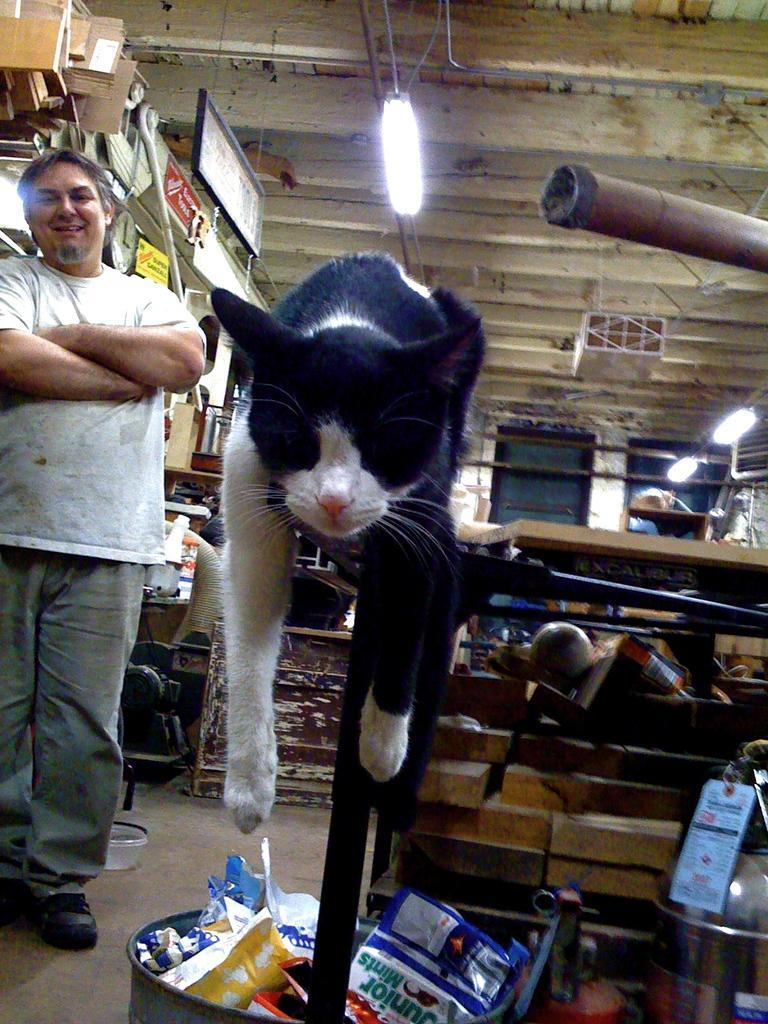Describe this image in one or two sentences. In this image, I can see a cat, which is black in color. At the bottom of the image, that looks like a dustbin with the wrappers. I think these are the wooden objects. On the left side of the image, I can see the man standing and smiling. I can see the cardboard boxes and few other objects. This is a tube light. I think this is a table. On the right side of the image, It looks like a pole. 